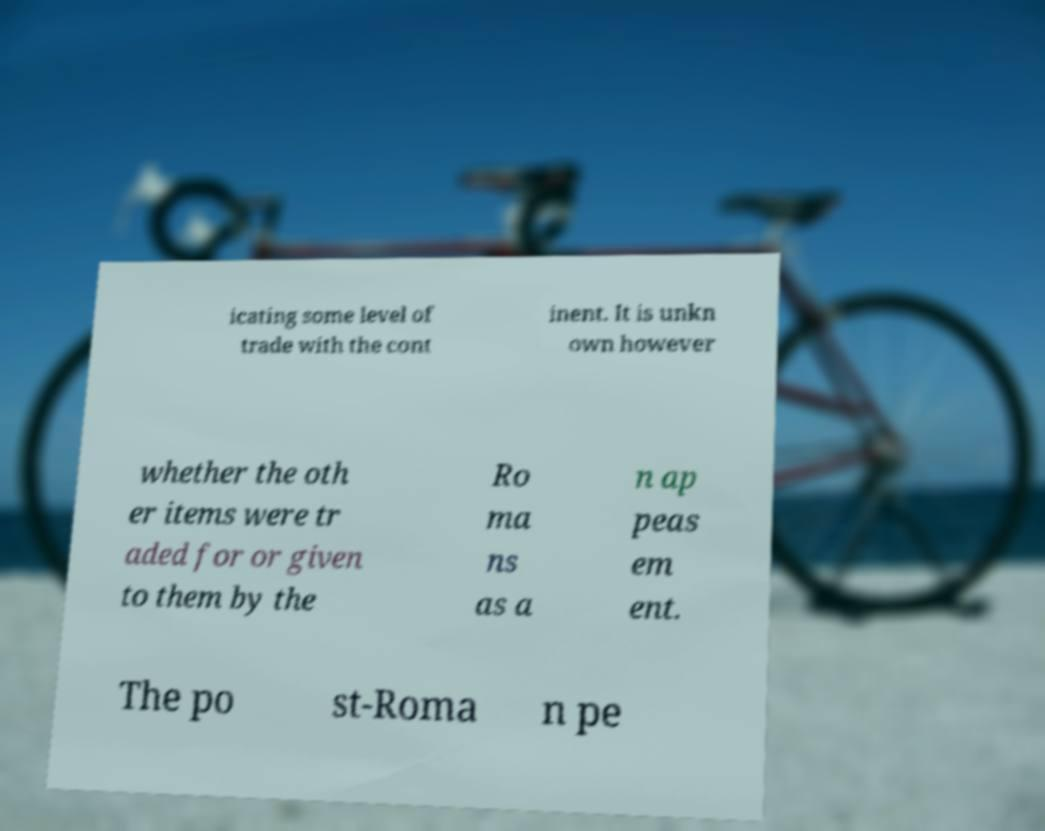Please read and relay the text visible in this image. What does it say? icating some level of trade with the cont inent. It is unkn own however whether the oth er items were tr aded for or given to them by the Ro ma ns as a n ap peas em ent. The po st-Roma n pe 